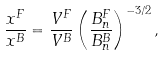<formula> <loc_0><loc_0><loc_500><loc_500>\frac { x ^ { F } } { x ^ { B } } = \frac { V ^ { F } } { V ^ { B } } \left ( \frac { B ^ { F } _ { n } } { B ^ { B } _ { n } } \right ) ^ { - 3 / 2 } ,</formula> 